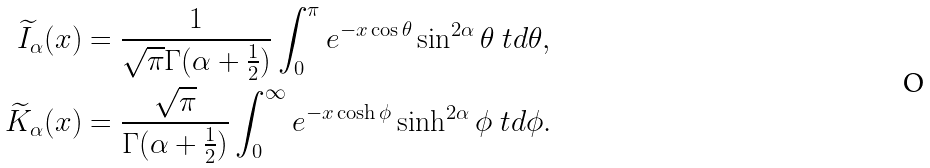Convert formula to latex. <formula><loc_0><loc_0><loc_500><loc_500>\widetilde { I } _ { \alpha } ( x ) & = \frac { 1 } { \sqrt { \pi } \Gamma ( \alpha + \frac { 1 } { 2 } ) } \int _ { 0 } ^ { \pi } { e ^ { - x \cos \theta } \sin ^ { 2 \alpha } \theta \ t d \theta } , \\ \widetilde { K } _ { \alpha } ( x ) & = \frac { \sqrt { \pi } } { \Gamma ( \alpha + \frac { 1 } { 2 } ) } \int _ { 0 } ^ { \infty } { e ^ { - x \cosh \phi } \sinh ^ { 2 \alpha } \phi \ t d \phi } .</formula> 